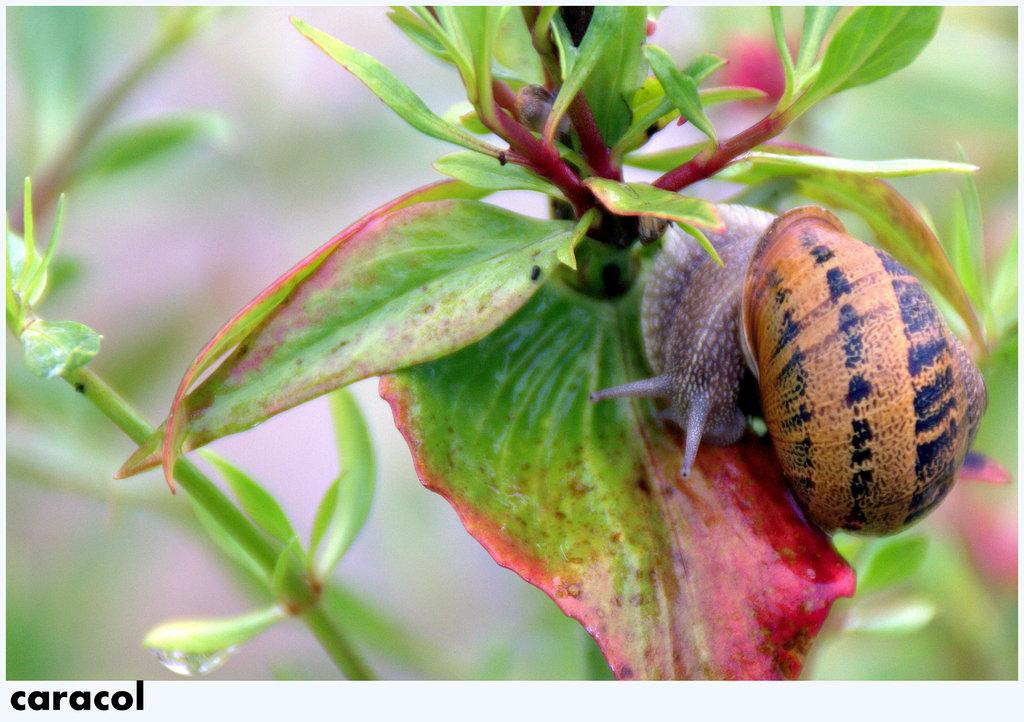What is the main subject of the image? There is a snail in the image. What is the snail standing on? The snail is standing on a leaf. What else can be seen in the image besides the snail? There is a plant in the image. What type of snow can be seen falling in the image? There is no snow present in the image; it features a snail standing on a leaf with a plant in the background. 